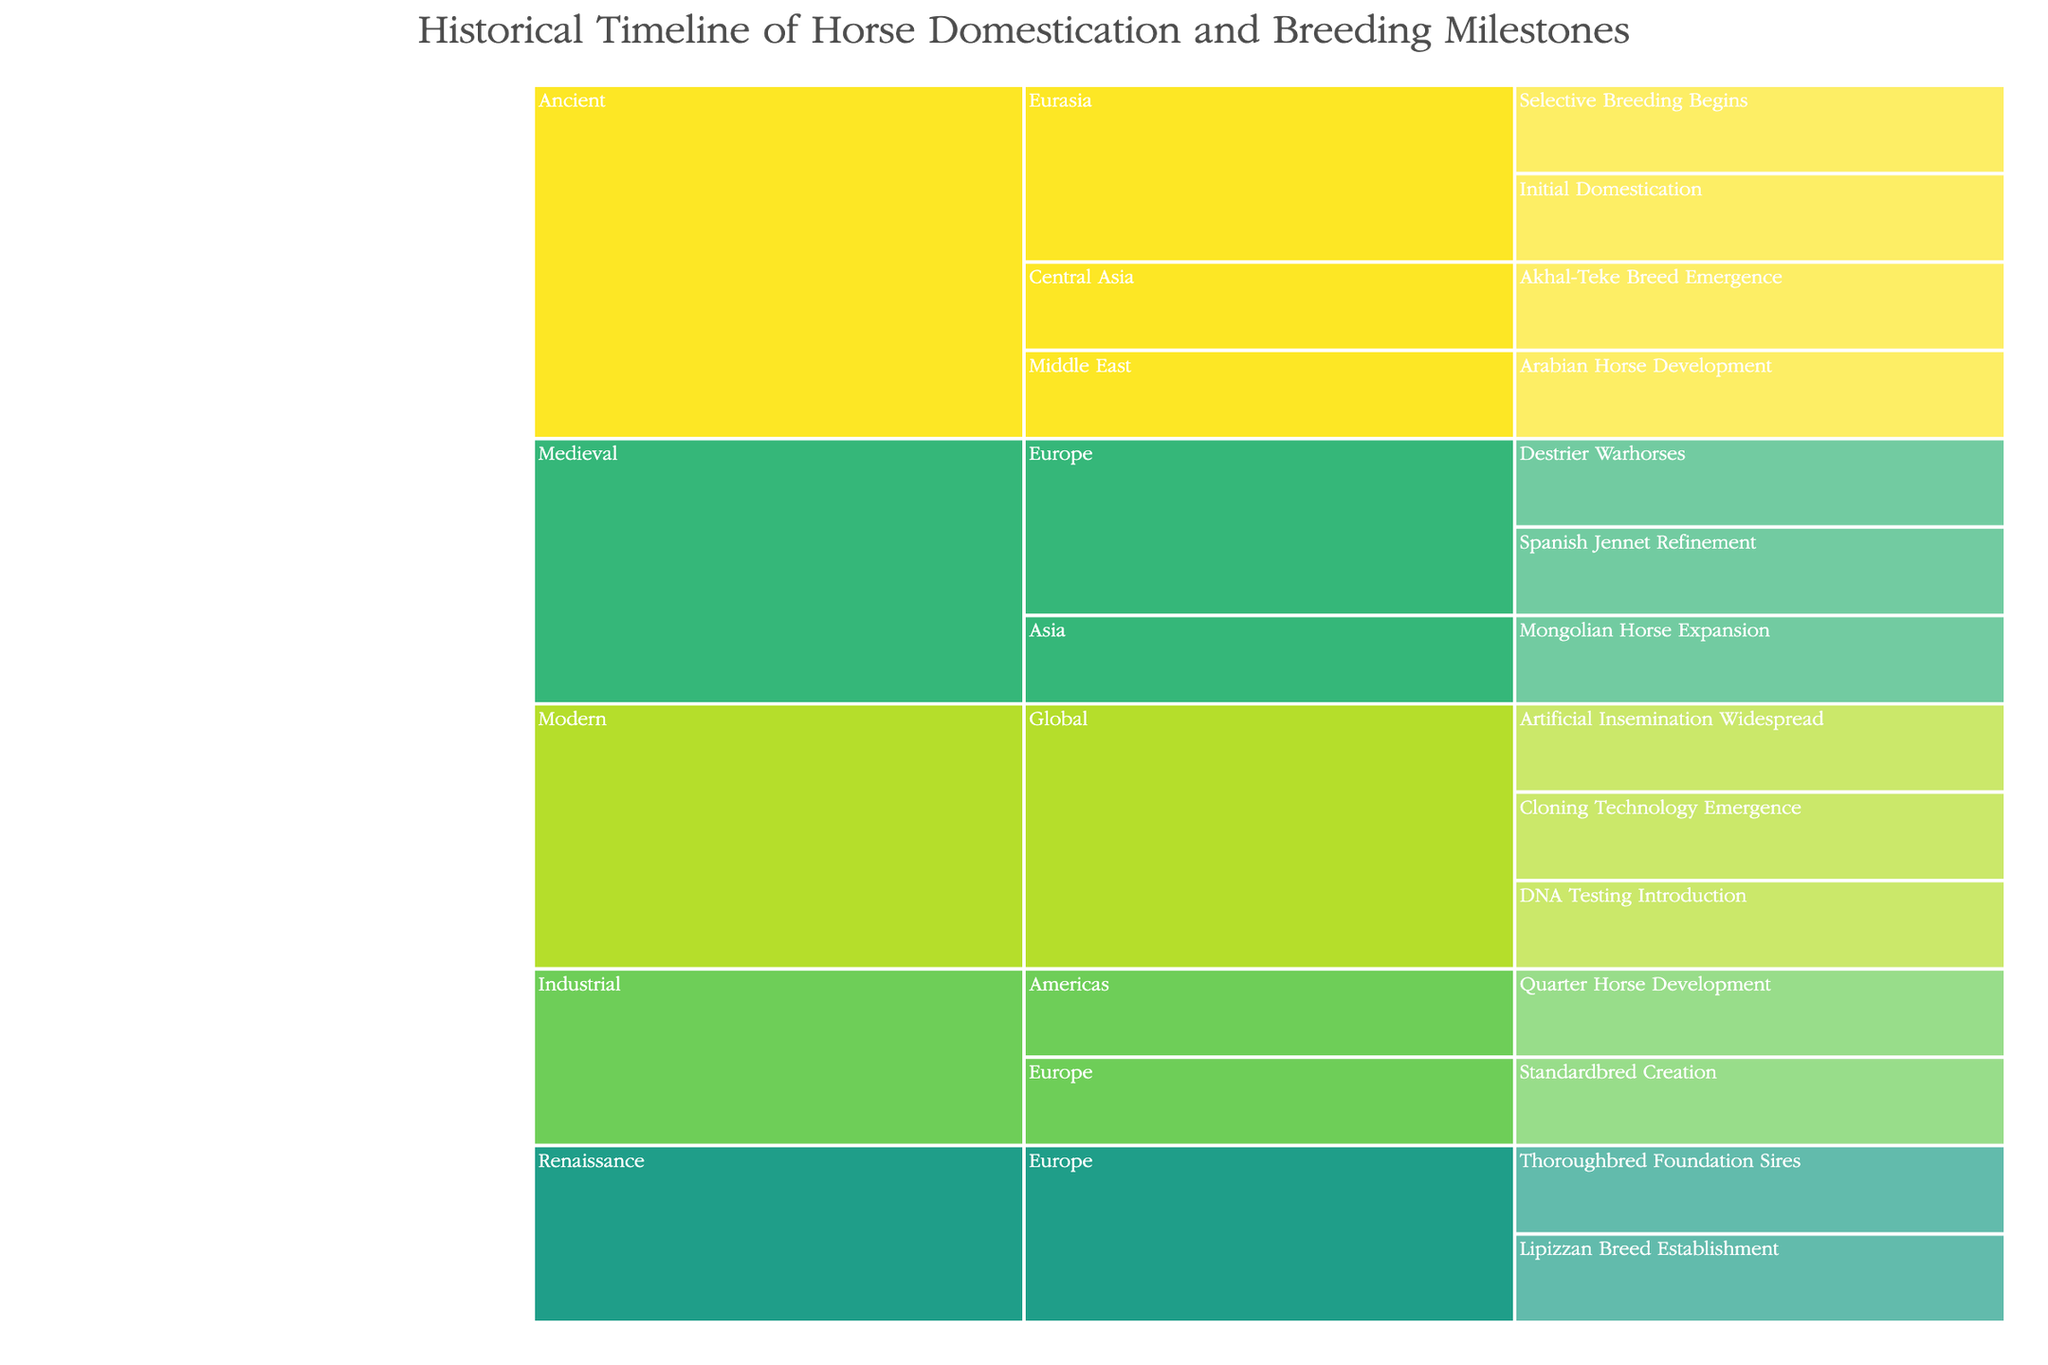What is the title of the icicle chart? The title of the icicle chart is located at the top center of the figure. It states, "Historical Timeline of Horse Domestication and Breeding Milestones."
Answer: Historical Timeline of Horse Domestication and Breeding Milestones Which era has the most milestones listed? To determine which era has the most milestones, count the number of unique milestones under each era in the icicle chart.
Answer: Modern What milestones are associated with the Ancient era in Eurasia? Look at the icicle branches under "Ancient" and then navigate to the "Eurasia" nodes to find the associated milestones.
Answer: Initial Domestication, Selective Breeding Begins Are there any breeding milestones listed for the Americas, and if so, in which era? Navigate through the icicle chart to find nodes that correspond to the Americas. Identify the era and the associated milestones if present.
Answer: Industrial, Quarter Horse Development Which region and era is associated with the Thoroughbred Foundation Sires milestone? Locate the Thoroughbred Foundation Sires milestone in the icicle chart and trace back to find the associated region and era.
Answer: Europe, Renaissance Compare the number of milestones in the Medieval era across Europe and Asia. Which region has more milestones? Count the milestones listed under the Medieval era for both Europe and Asia and compare the totals.
Answer: Europe How many global milestones are listed in the Modern era? Navigate to the Modern era and count the number of milestones under the "Global" node.
Answer: Three What milestone is listed in Central Asia within the Ancient era? Find the Ancient era, then locate the Central Asia region, and identify the milestone listed under it.
Answer: Akhal-Teke Breed Emergence Do the Americas have any milestones listed in the Renaissance era? Navigate to the Renaissance era in the icicle chart and look for branches corresponding to the Americas region.
Answer: No 